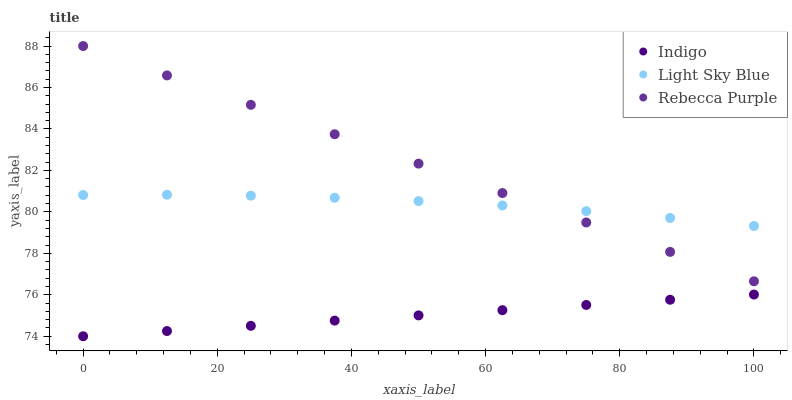Does Indigo have the minimum area under the curve?
Answer yes or no. Yes. Does Rebecca Purple have the maximum area under the curve?
Answer yes or no. Yes. Does Rebecca Purple have the minimum area under the curve?
Answer yes or no. No. Does Indigo have the maximum area under the curve?
Answer yes or no. No. Is Indigo the smoothest?
Answer yes or no. Yes. Is Light Sky Blue the roughest?
Answer yes or no. Yes. Is Rebecca Purple the smoothest?
Answer yes or no. No. Is Rebecca Purple the roughest?
Answer yes or no. No. Does Indigo have the lowest value?
Answer yes or no. Yes. Does Rebecca Purple have the lowest value?
Answer yes or no. No. Does Rebecca Purple have the highest value?
Answer yes or no. Yes. Does Indigo have the highest value?
Answer yes or no. No. Is Indigo less than Rebecca Purple?
Answer yes or no. Yes. Is Light Sky Blue greater than Indigo?
Answer yes or no. Yes. Does Light Sky Blue intersect Rebecca Purple?
Answer yes or no. Yes. Is Light Sky Blue less than Rebecca Purple?
Answer yes or no. No. Is Light Sky Blue greater than Rebecca Purple?
Answer yes or no. No. Does Indigo intersect Rebecca Purple?
Answer yes or no. No. 